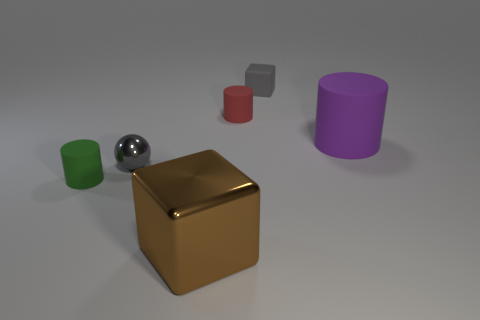The small cylinder to the left of the brown metallic thing is what color?
Provide a succinct answer. Green. Is the size of the thing in front of the green matte thing the same as the cylinder that is left of the metallic cube?
Offer a very short reply. No. Are there any green things that have the same size as the red matte cylinder?
Your answer should be compact. Yes. How many metal spheres are in front of the small matte cylinder right of the large brown object?
Provide a short and direct response. 1. What is the large brown block made of?
Your response must be concise. Metal. What number of green matte cylinders are on the left side of the big metal thing?
Your answer should be compact. 1. Does the small cube have the same color as the sphere?
Make the answer very short. Yes. What number of things are the same color as the rubber cube?
Make the answer very short. 1. Is the number of tiny red things greater than the number of yellow metal spheres?
Provide a succinct answer. Yes. What size is the object that is both in front of the tiny red rubber cylinder and on the right side of the brown metal block?
Ensure brevity in your answer.  Large. 